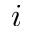Convert formula to latex. <formula><loc_0><loc_0><loc_500><loc_500>i</formula> 